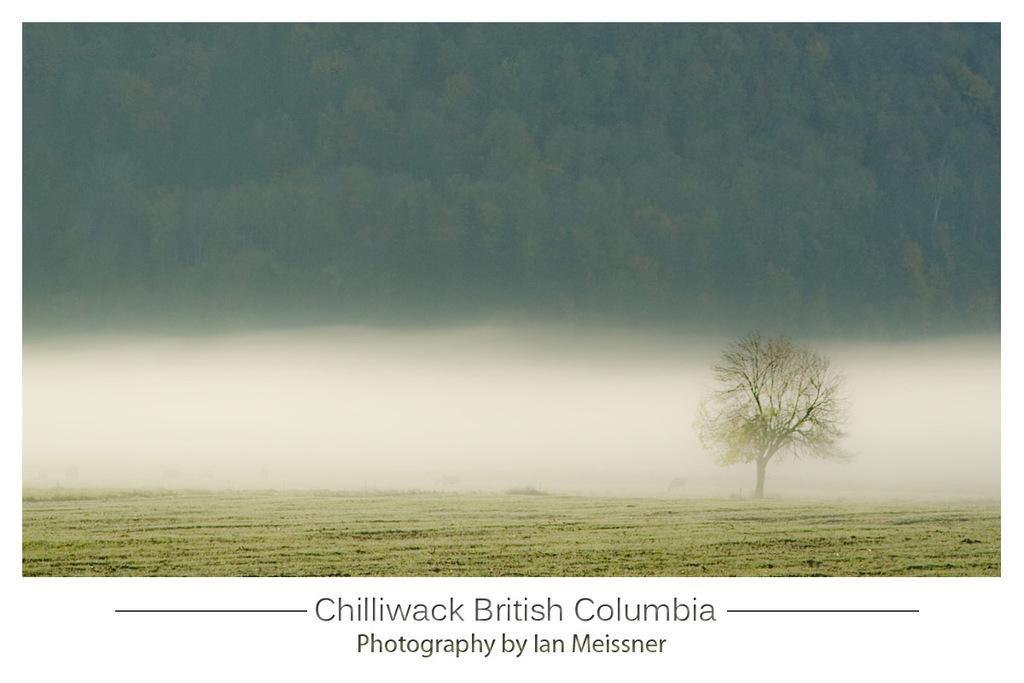Can you describe this image briefly? In this picture we can see grass on the ground and in the background we can see trees, at the bottom we can see some text. 